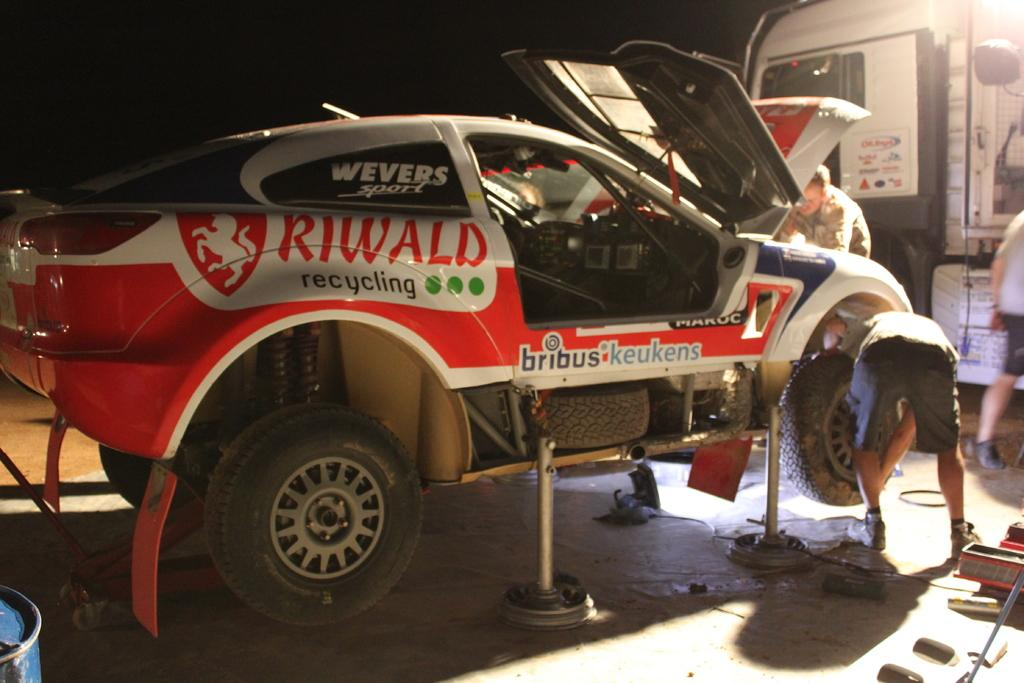What types of objects are present in the image? There are vehicles, three persons, and tools in the image. Can you describe the people in the image? There are three persons in the image. What is the color of the background in the image? The background of the image is dark. What historical event is being commemorated by the minister in the image? There is no minister or historical event present in the image. What type of government is depicted in the image? There is no government depicted in the image. 